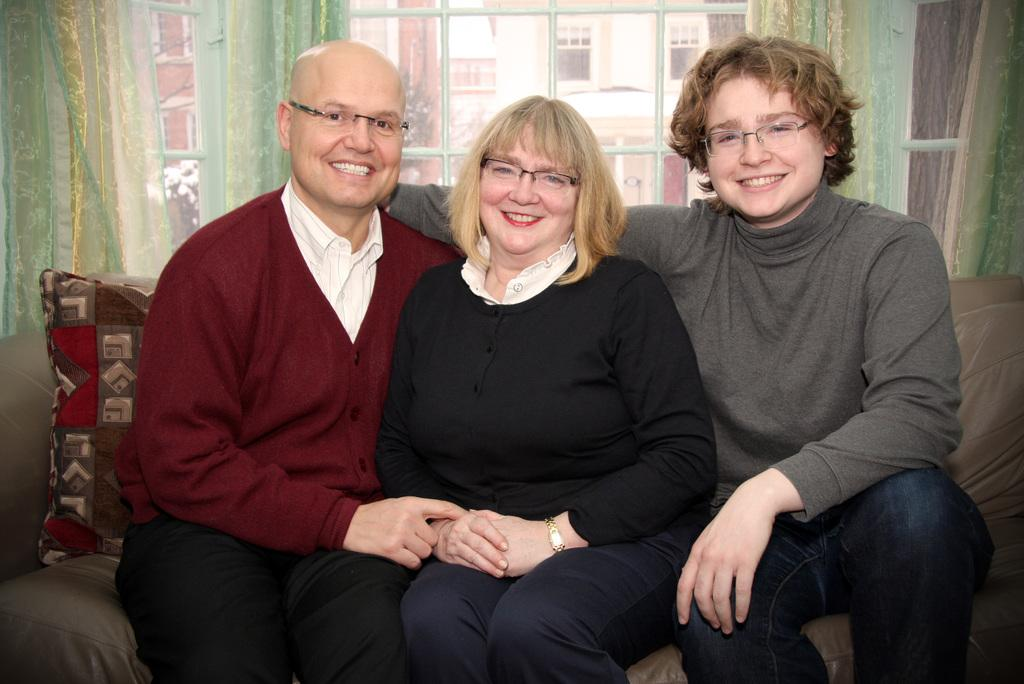How many people are in the image? There are three persons in the image. Can you describe the gender of the persons? Two of the persons are men, and one is a woman. Where are the persons sitting in the image? The three persons are sitting on a couch. What is visible in the background of the image? There is a window in the background of the image, and buildings are visible through the window. Is there any window treatment present in the image? Yes, there is a curtain associated with the window. What level of expertise do the mice have in the image? There are no mice present in the image, so it is not possible to determine their level of expertise. 